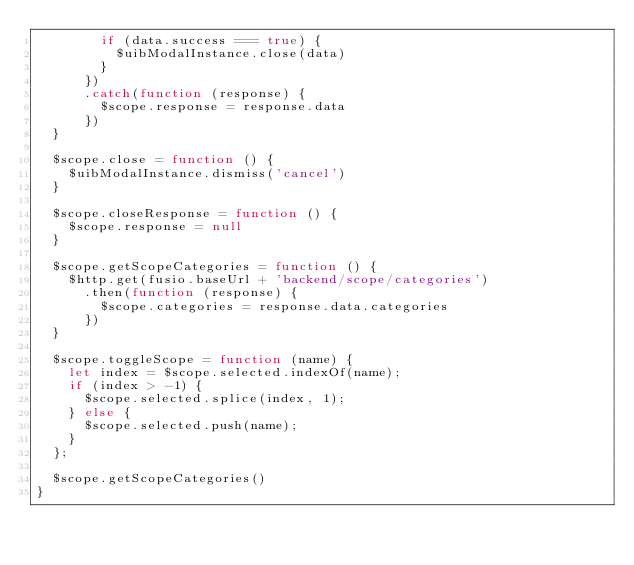Convert code to text. <code><loc_0><loc_0><loc_500><loc_500><_JavaScript_>        if (data.success === true) {
          $uibModalInstance.close(data)
        }
      })
      .catch(function (response) {
        $scope.response = response.data
      })
  }

  $scope.close = function () {
    $uibModalInstance.dismiss('cancel')
  }

  $scope.closeResponse = function () {
    $scope.response = null
  }

  $scope.getScopeCategories = function () {
    $http.get(fusio.baseUrl + 'backend/scope/categories')
      .then(function (response) {
        $scope.categories = response.data.categories
      })
  }

  $scope.toggleScope = function (name) {
    let index = $scope.selected.indexOf(name);
    if (index > -1) {
      $scope.selected.splice(index, 1);
    } else {
      $scope.selected.push(name);
    }
  };

  $scope.getScopeCategories()
}
</code> 